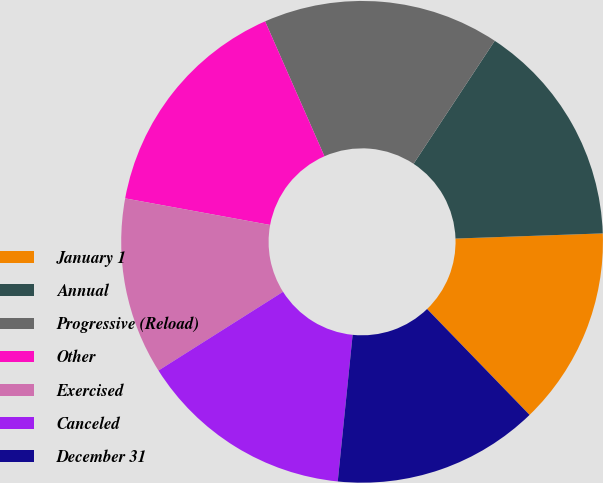<chart> <loc_0><loc_0><loc_500><loc_500><pie_chart><fcel>January 1<fcel>Annual<fcel>Progressive (Reload)<fcel>Other<fcel>Exercised<fcel>Canceled<fcel>December 31<nl><fcel>13.32%<fcel>15.16%<fcel>15.88%<fcel>15.52%<fcel>11.86%<fcel>14.42%<fcel>13.85%<nl></chart> 